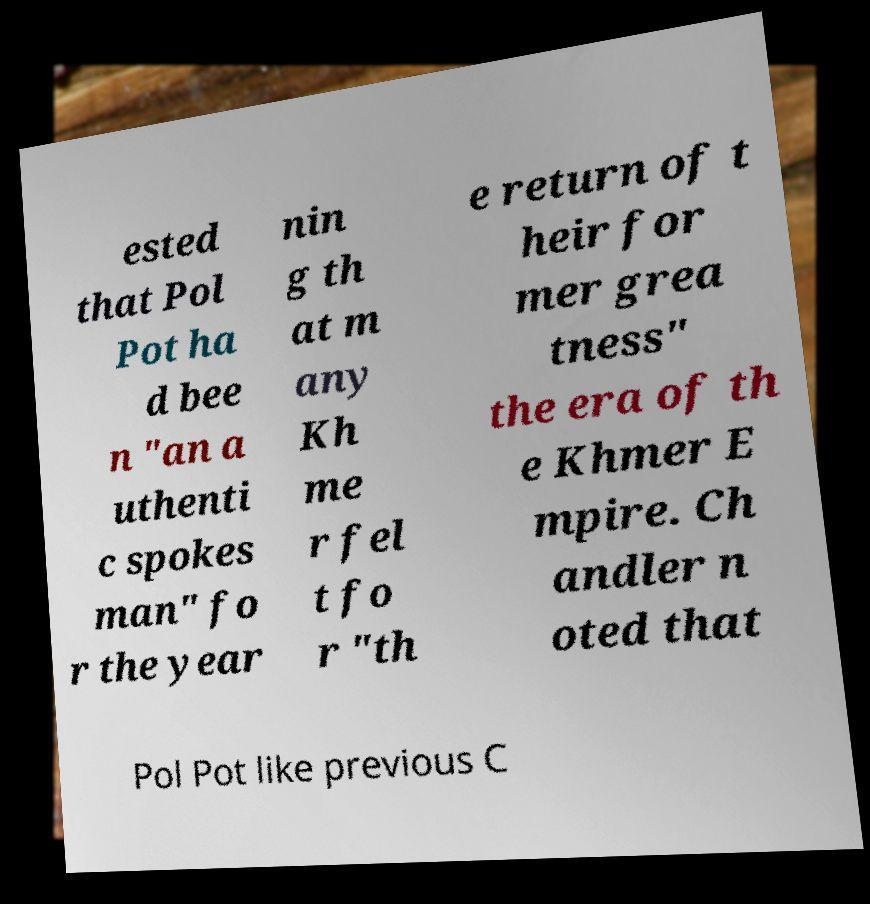Can you accurately transcribe the text from the provided image for me? ested that Pol Pot ha d bee n "an a uthenti c spokes man" fo r the year nin g th at m any Kh me r fel t fo r "th e return of t heir for mer grea tness" the era of th e Khmer E mpire. Ch andler n oted that Pol Pot like previous C 